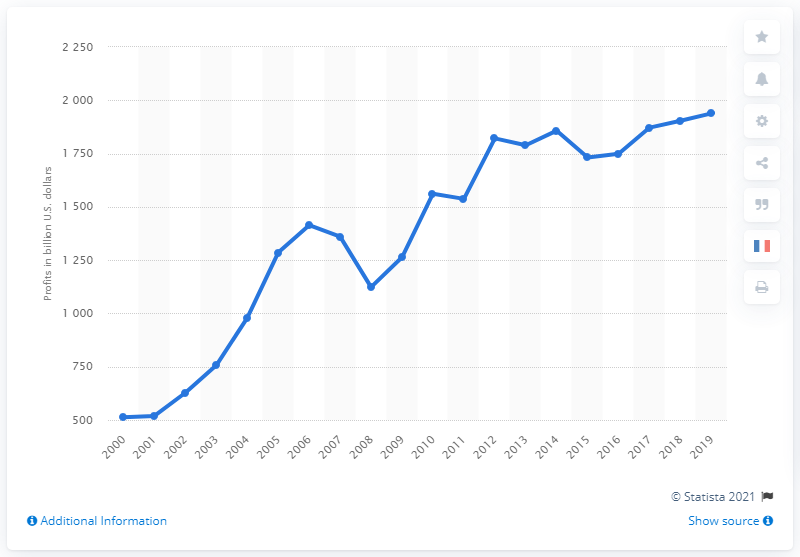Indicate a few pertinent items in this graphic. In 2019, corporations made a total of $193,858.00 in dollars. 